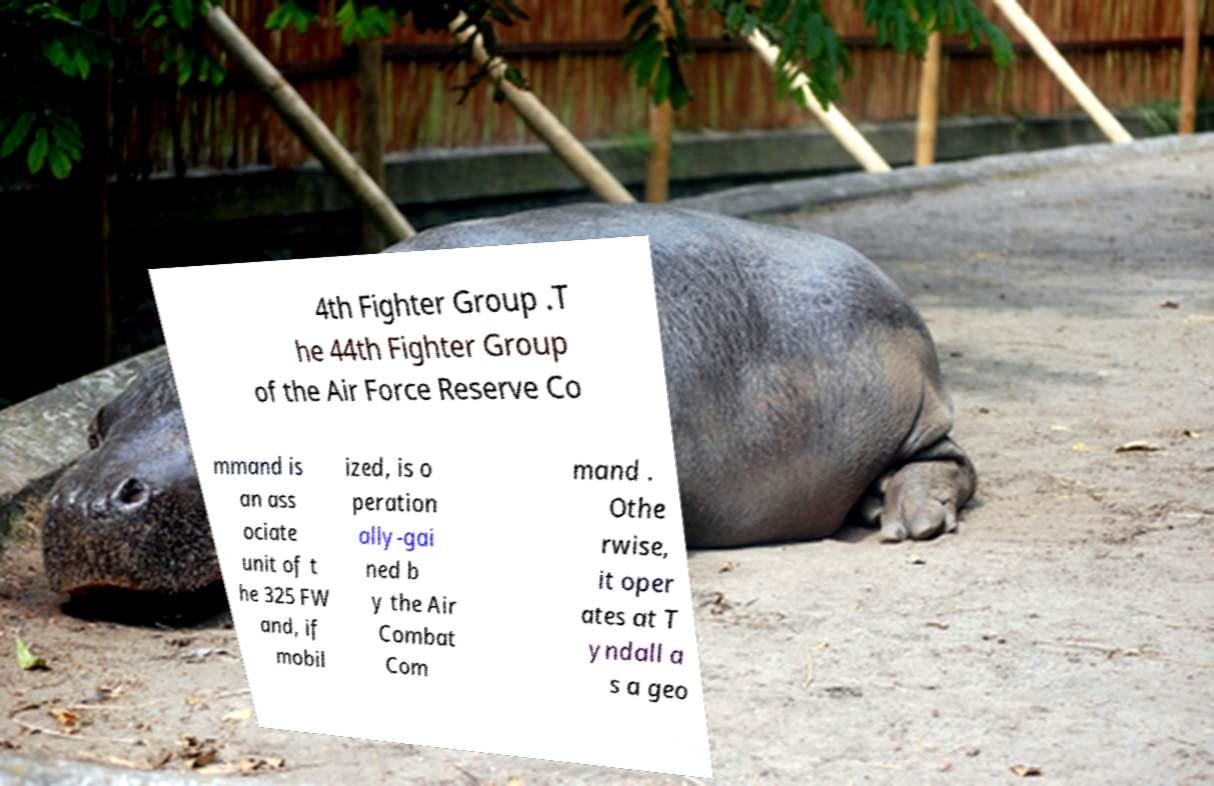Please identify and transcribe the text found in this image. 4th Fighter Group .T he 44th Fighter Group of the Air Force Reserve Co mmand is an ass ociate unit of t he 325 FW and, if mobil ized, is o peration ally-gai ned b y the Air Combat Com mand . Othe rwise, it oper ates at T yndall a s a geo 